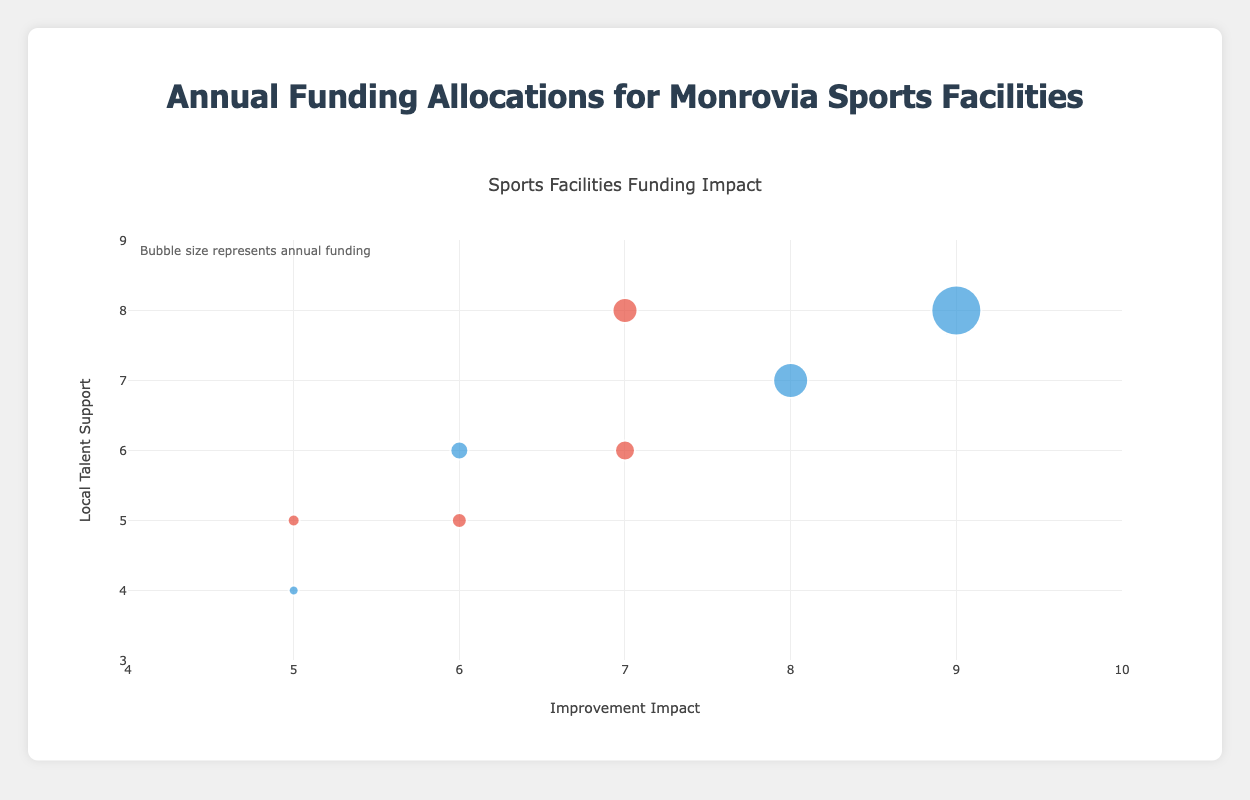What facility has the highest annual funding? From the legend, we can see that the bubble size represents the annual funding. The largest bubble is for the Samuel Kanyon Doe Sports Complex.
Answer: Samuel Kanyon Doe Sports Complex Which facilities are funded by private organizations? From the color coding of the bubbles, we know that red bubbles represent private organizations. In the chart, the facilities with red bubbles are Barnersville Sports Club, New Georgia Multipurpose Center, Ducor Athletic Club, and Paynesville Youth Sports Center.
Answer: Barnersville Sports Club, New Georgia Multipurpose Center, Ducor Athletic Club, Paynesville Youth Sports Center What is the improvement impact of Antoinette Tubman Stadium compared to the New Georgia Multipurpose Center? Find the x coordinates of both facilities’ bubbles. Antoinette Tubman Stadium is at 8 and New Georgia Multipurpose Center is at 7.
Answer: Antoinette Tubman Stadium has a higher improvement impact Which facility provides the highest local talent support and what is its funding source? Observe the y-axis for the highest value and locate the corresponding bubble. The highest local talent support score is 8, which corresponds to Samuel Kanyon Doe Sports Complex, funded by the government.
Answer: Samuel Kanyon Doe Sports Complex, Government What is the range of improvement impact represented on the x-axis? The x-axis title indicates "Improvement Impact," and the range is given as 4 to 10.
Answer: 4 to 10 Compare the local talent support of Monrovia Community Sports Center and Paynesville Youth Sports Center. Which one is higher? Locate the y coordinates of both bubbles. Monrovia Community Sports Center is at 6, and Paynesville Youth Sports Center is at 5.
Answer: Monrovia Community Sports Center What can you infer about the bubble representing the University of Liberia Sports Grounds in terms of its funding and overall impact? Its bubble's color indicates government funding, its small size suggests low funding ($100,000), and its x and y coordinates (5 and 4) imply both low improvement impact and low local talent support.
Answer: Government funded with low funding, low impact, and low talent support How does the funding of Ducor Athletic Club compare with Barnersville Sports Club considering their bubble sizes? Both are funded by private organizations (red color), but Ducor Athletic Club has a larger bubble than Barnersville Sports Club, indicating higher funding ($250,000 vs. $150,000).
Answer: Ducor Athletic Club has higher funding Summarize the pattern of funding sources depicted in the bubble colors. Bubbles colored in blue represent government funding, while bubbles colored in red represent private organization funding. The chart shows a mix of both funding sources with no clear dominance.
Answer: Mixed with both government and private funding 